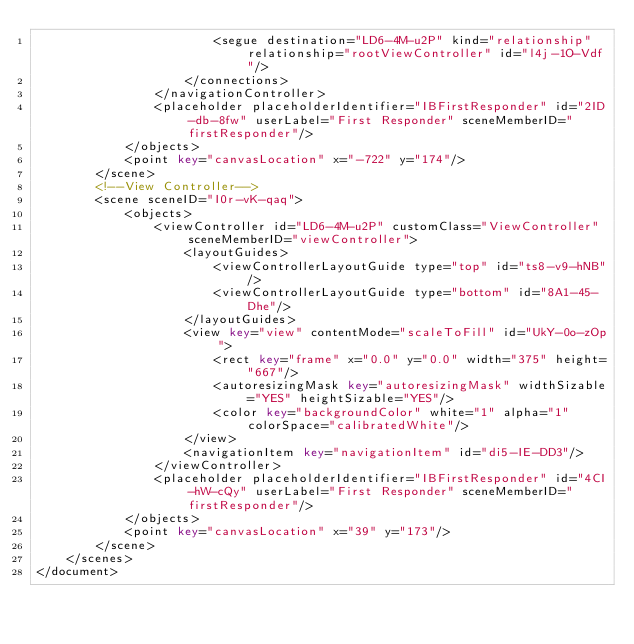Convert code to text. <code><loc_0><loc_0><loc_500><loc_500><_XML_>                        <segue destination="LD6-4M-u2P" kind="relationship" relationship="rootViewController" id="l4j-1O-Vdf"/>
                    </connections>
                </navigationController>
                <placeholder placeholderIdentifier="IBFirstResponder" id="2ID-db-8fw" userLabel="First Responder" sceneMemberID="firstResponder"/>
            </objects>
            <point key="canvasLocation" x="-722" y="174"/>
        </scene>
        <!--View Controller-->
        <scene sceneID="I0r-vK-qaq">
            <objects>
                <viewController id="LD6-4M-u2P" customClass="ViewController" sceneMemberID="viewController">
                    <layoutGuides>
                        <viewControllerLayoutGuide type="top" id="ts8-v9-hNB"/>
                        <viewControllerLayoutGuide type="bottom" id="8A1-45-Dhe"/>
                    </layoutGuides>
                    <view key="view" contentMode="scaleToFill" id="UkY-0o-zOp">
                        <rect key="frame" x="0.0" y="0.0" width="375" height="667"/>
                        <autoresizingMask key="autoresizingMask" widthSizable="YES" heightSizable="YES"/>
                        <color key="backgroundColor" white="1" alpha="1" colorSpace="calibratedWhite"/>
                    </view>
                    <navigationItem key="navigationItem" id="di5-IE-DD3"/>
                </viewController>
                <placeholder placeholderIdentifier="IBFirstResponder" id="4CI-hW-cQy" userLabel="First Responder" sceneMemberID="firstResponder"/>
            </objects>
            <point key="canvasLocation" x="39" y="173"/>
        </scene>
    </scenes>
</document>
</code> 